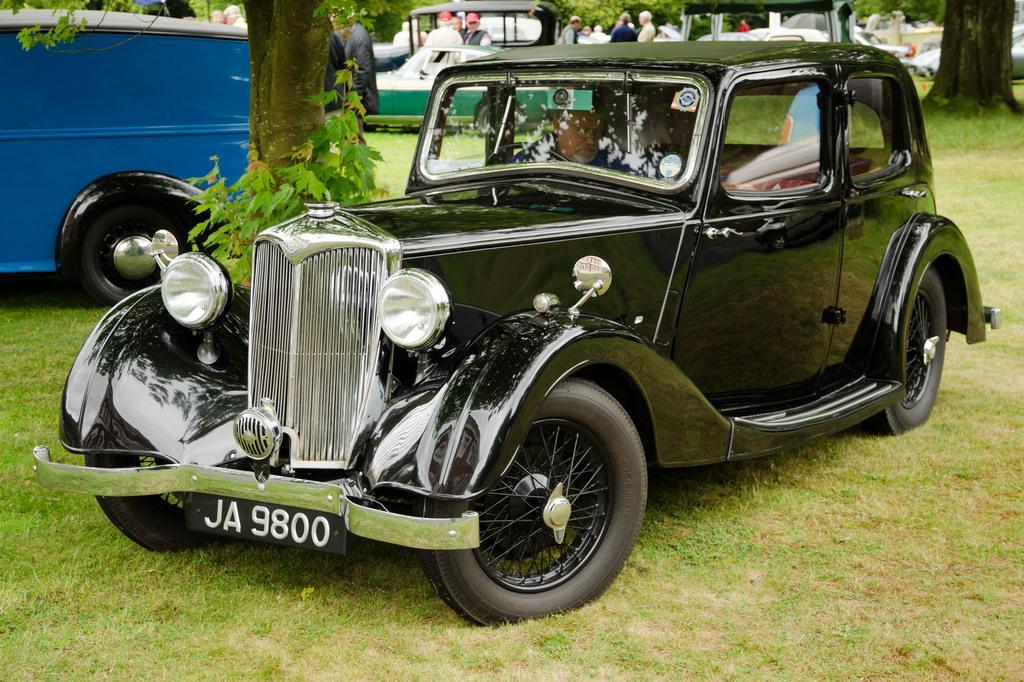Describe this image in one or two sentences. In this picture I can see some vehicles are on the grass, around we can see few people and also we can see some trees. 